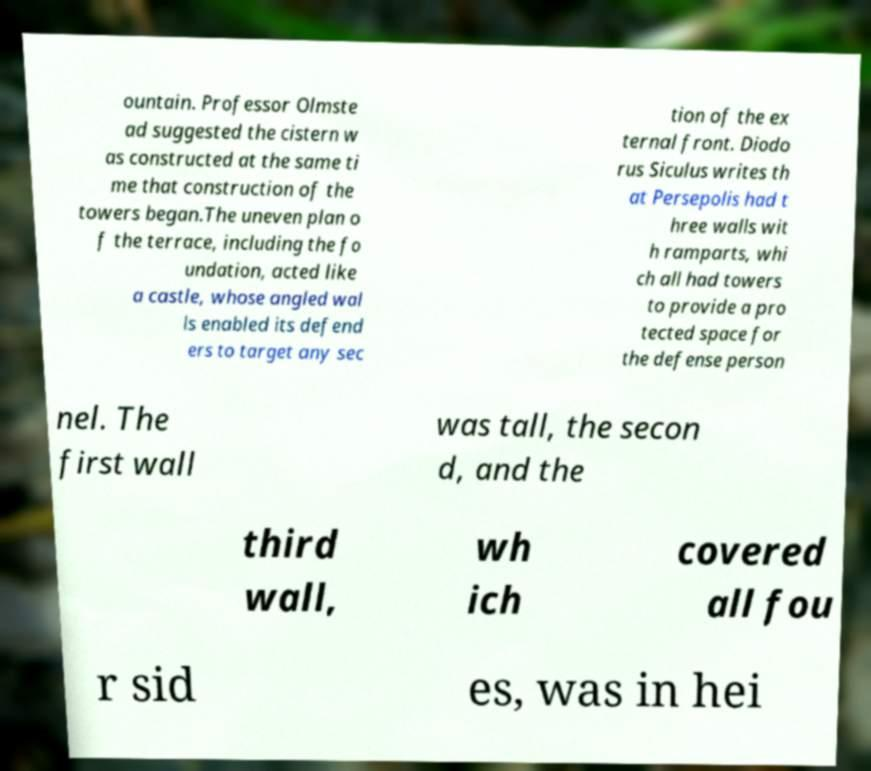Can you accurately transcribe the text from the provided image for me? ountain. Professor Olmste ad suggested the cistern w as constructed at the same ti me that construction of the towers began.The uneven plan o f the terrace, including the fo undation, acted like a castle, whose angled wal ls enabled its defend ers to target any sec tion of the ex ternal front. Diodo rus Siculus writes th at Persepolis had t hree walls wit h ramparts, whi ch all had towers to provide a pro tected space for the defense person nel. The first wall was tall, the secon d, and the third wall, wh ich covered all fou r sid es, was in hei 